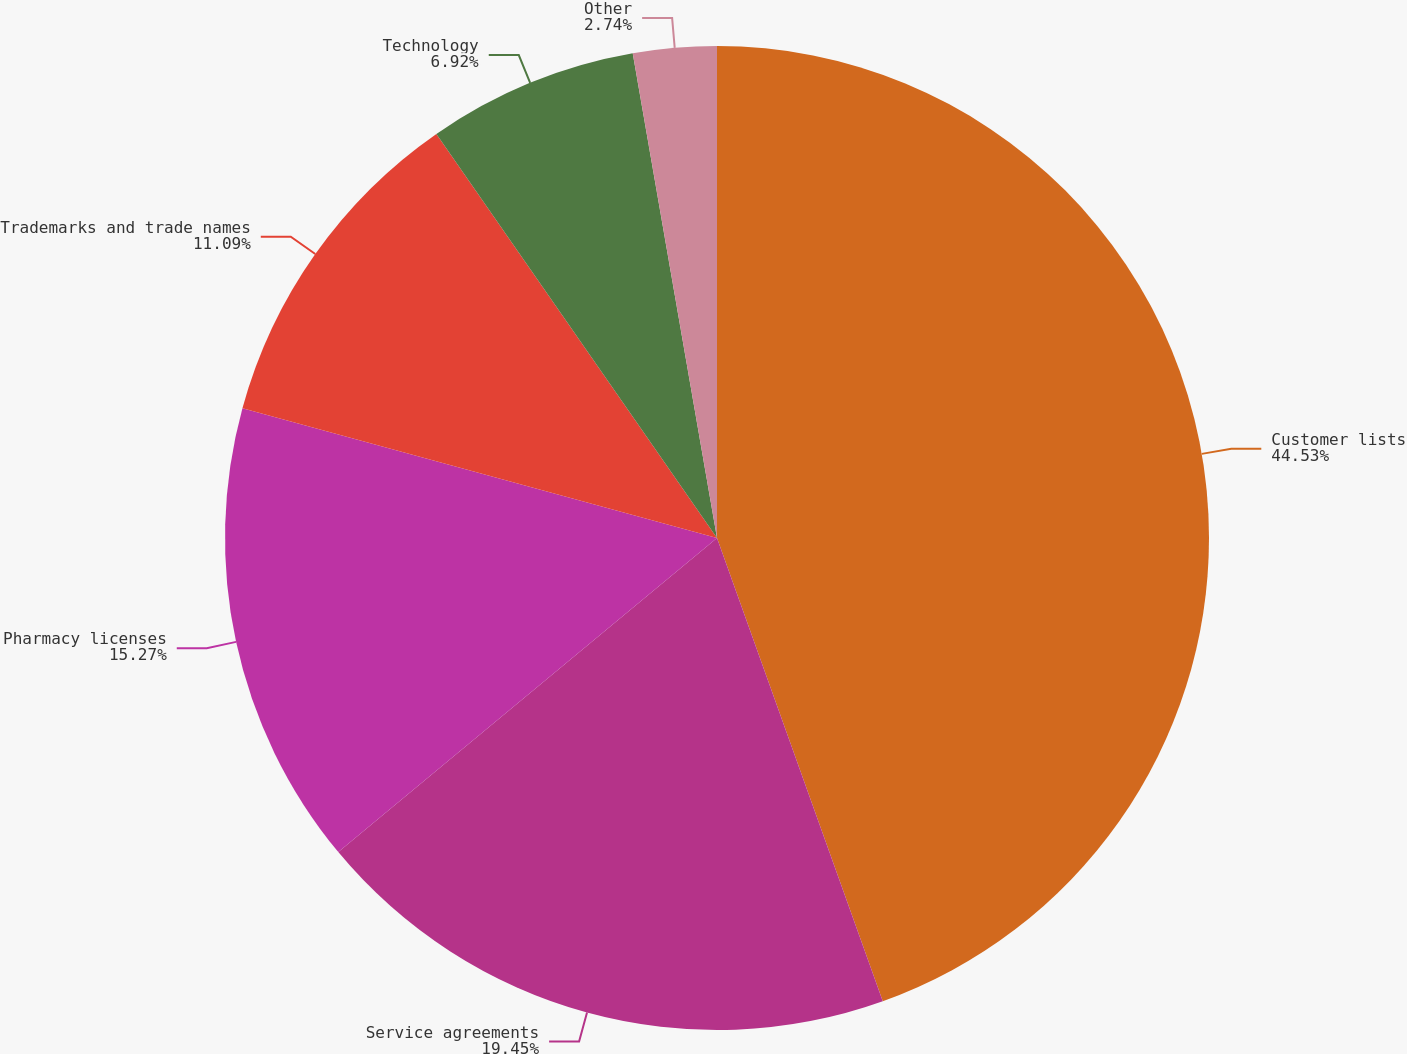Convert chart. <chart><loc_0><loc_0><loc_500><loc_500><pie_chart><fcel>Customer lists<fcel>Service agreements<fcel>Pharmacy licenses<fcel>Trademarks and trade names<fcel>Technology<fcel>Other<nl><fcel>44.53%<fcel>19.45%<fcel>15.27%<fcel>11.09%<fcel>6.92%<fcel>2.74%<nl></chart> 